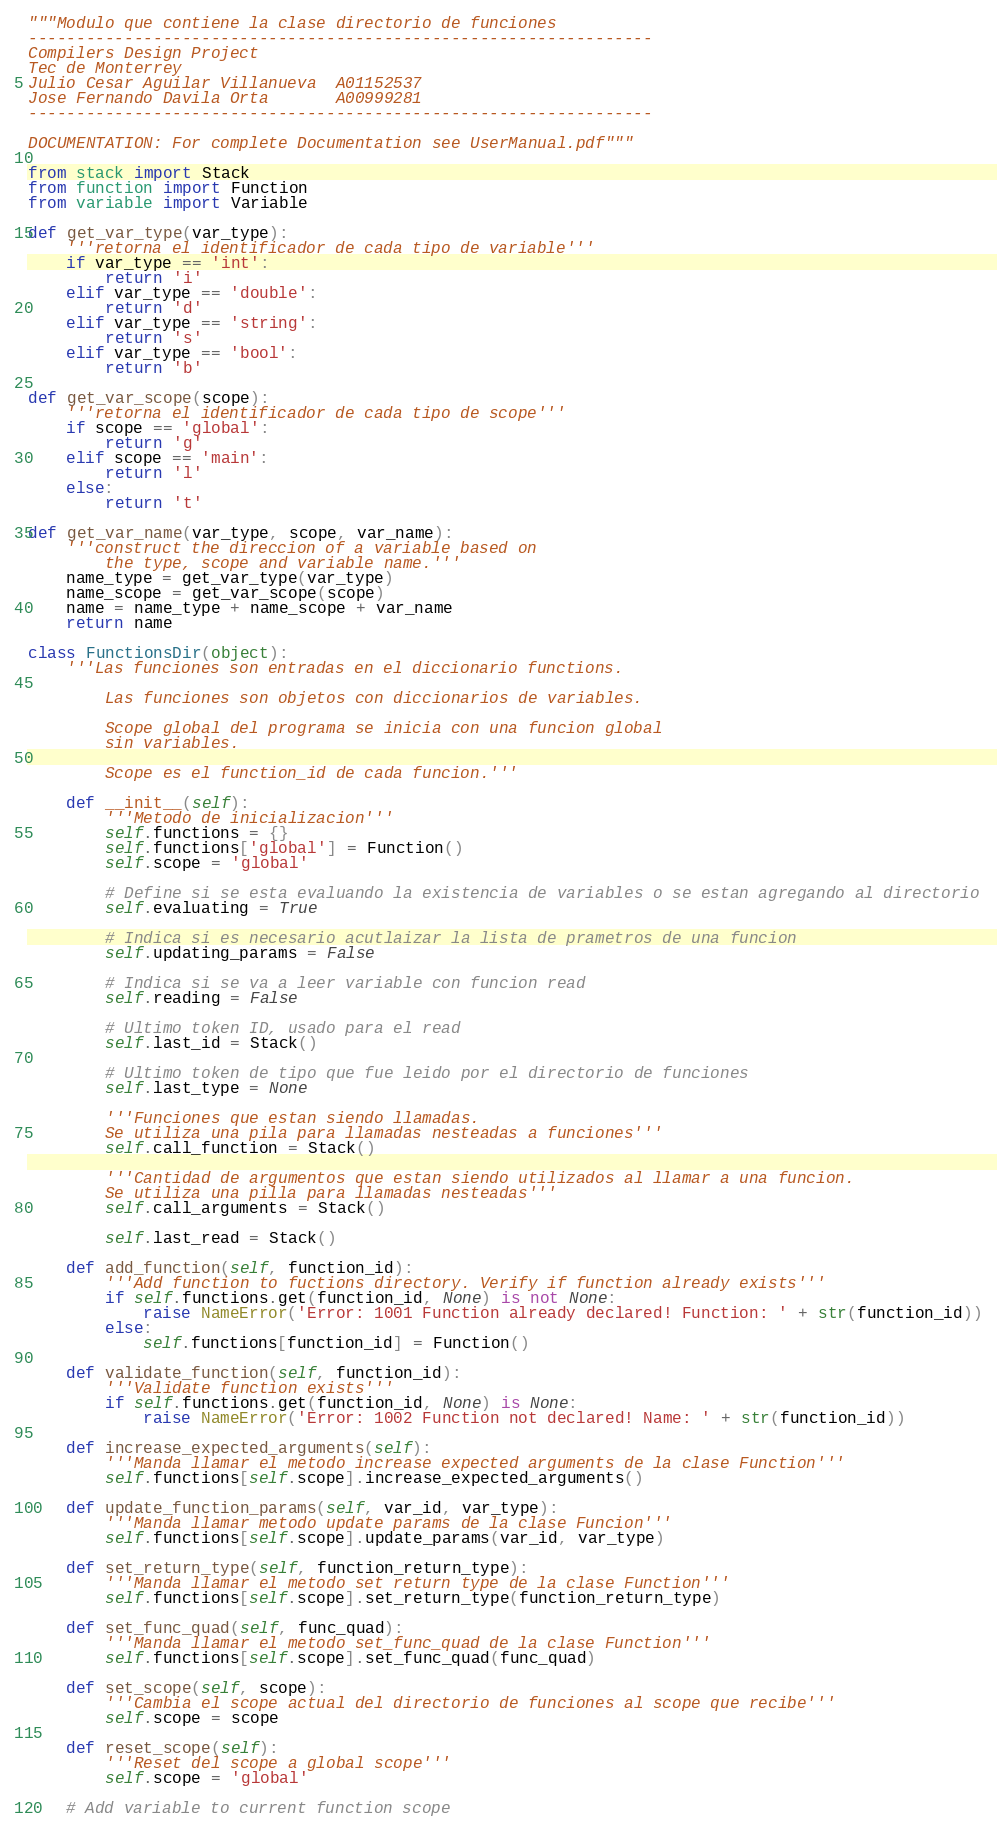Convert code to text. <code><loc_0><loc_0><loc_500><loc_500><_Python_>"""Modulo que contiene la clase directorio de funciones
-----------------------------------------------------------------
Compilers Design Project
Tec de Monterrey
Julio Cesar Aguilar Villanueva  A01152537
Jose Fernando Davila Orta       A00999281
-----------------------------------------------------------------

DOCUMENTATION: For complete Documentation see UserManual.pdf"""

from stack import Stack
from function import Function
from variable import Variable

def get_var_type(var_type):
    '''retorna el identificador de cada tipo de variable'''
    if var_type == 'int':
        return 'i'
    elif var_type == 'double':
        return 'd'
    elif var_type == 'string':
        return 's'
    elif var_type == 'bool':
        return 'b'

def get_var_scope(scope):
    '''retorna el identificador de cada tipo de scope'''
    if scope == 'global':
        return 'g'
    elif scope == 'main':
        return 'l'
    else:
        return 't'

def get_var_name(var_type, scope, var_name):
    '''construct the direccion of a variable based on
        the type, scope and variable name.'''
    name_type = get_var_type(var_type)
    name_scope = get_var_scope(scope)
    name = name_type + name_scope + var_name
    return name

class FunctionsDir(object):
    '''Las funciones son entradas en el diccionario functions.

        Las funciones son objetos con diccionarios de variables.

        Scope global del programa se inicia con una funcion global
        sin variables.

        Scope es el function_id de cada funcion.'''

    def __init__(self):
        '''Metodo de inicializacion'''
        self.functions = {}
        self.functions['global'] = Function()
        self.scope = 'global'

        # Define si se esta evaluando la existencia de variables o se estan agregando al directorio
        self.evaluating = True

        # Indica si es necesario acutlaizar la lista de prametros de una funcion
        self.updating_params = False

        # Indica si se va a leer variable con funcion read
        self.reading = False

        # Ultimo token ID, usado para el read
        self.last_id = Stack()

        # Ultimo token de tipo que fue leido por el directorio de funciones
        self.last_type = None

        '''Funciones que estan siendo llamadas.
        Se utiliza una pila para llamadas nesteadas a funciones'''
        self.call_function = Stack()

        '''Cantidad de argumentos que estan siendo utilizados al llamar a una funcion.
        Se utiliza una pilla para llamadas nesteadas'''
        self.call_arguments = Stack()

        self.last_read = Stack()

    def add_function(self, function_id):
        '''Add function to fuctions directory. Verify if function already exists'''
        if self.functions.get(function_id, None) is not None:
            raise NameError('Error: 1001 Function already declared! Function: ' + str(function_id))
        else:
            self.functions[function_id] = Function()

    def validate_function(self, function_id):
        '''Validate function exists'''
        if self.functions.get(function_id, None) is None:
            raise NameError('Error: 1002 Function not declared! Name: ' + str(function_id))

    def increase_expected_arguments(self):
        '''Manda llamar el metodo increase expected arguments de la clase Function'''
        self.functions[self.scope].increase_expected_arguments()

    def update_function_params(self, var_id, var_type):
        '''Manda llamar metodo update params de la clase Funcion'''
        self.functions[self.scope].update_params(var_id, var_type)

    def set_return_type(self, function_return_type):
        '''Manda llamar el metodo set return type de la clase Function'''
        self.functions[self.scope].set_return_type(function_return_type)

    def set_func_quad(self, func_quad):
        '''Manda llamar el metodo set_func_quad de la clase Function'''
        self.functions[self.scope].set_func_quad(func_quad)

    def set_scope(self, scope):
        '''Cambia el scope actual del directorio de funciones al scope que recibe'''
        self.scope = scope

    def reset_scope(self):
        '''Reset del scope a global scope'''
        self.scope = 'global'

    # Add variable to current function scope</code> 